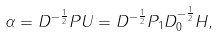Convert formula to latex. <formula><loc_0><loc_0><loc_500><loc_500>\alpha = D ^ { - \frac { 1 } { 2 } } P U = D ^ { - \frac { 1 } { 2 } } P _ { 1 } D _ { 0 } ^ { - \frac { 1 } { 2 } } H ,</formula> 